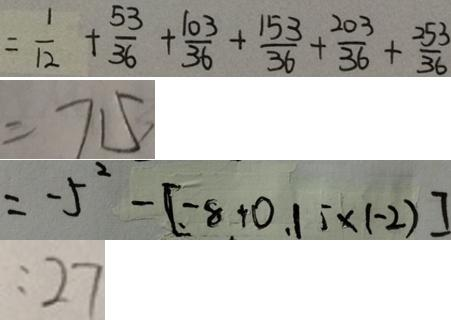Convert formula to latex. <formula><loc_0><loc_0><loc_500><loc_500>= \frac { 1 } { 1 2 } + \frac { 5 3 } { 3 6 } + \frac { 1 0 3 } { 3 6 } + \frac { 1 5 3 } { 3 6 } + \frac { 2 0 3 } { 3 6 } + \frac { 2 5 3 } { 3 6 } 
 = 7 1 5 
 = - 5 ^ { 2 } - [ - 8 + 0 . 1 \times ( - 2 ) ] 
 : 2 7</formula> 